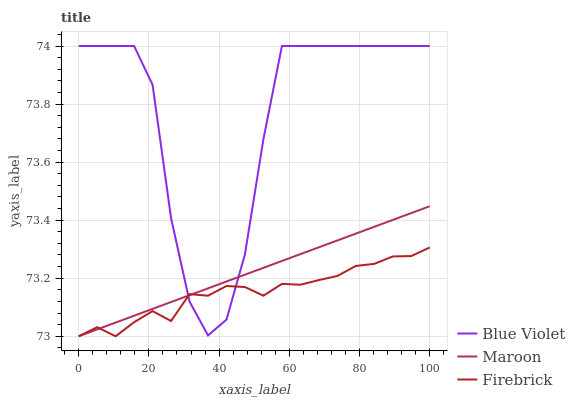Does Firebrick have the minimum area under the curve?
Answer yes or no. Yes. Does Blue Violet have the maximum area under the curve?
Answer yes or no. Yes. Does Maroon have the minimum area under the curve?
Answer yes or no. No. Does Maroon have the maximum area under the curve?
Answer yes or no. No. Is Maroon the smoothest?
Answer yes or no. Yes. Is Blue Violet the roughest?
Answer yes or no. Yes. Is Blue Violet the smoothest?
Answer yes or no. No. Is Maroon the roughest?
Answer yes or no. No. Does Firebrick have the lowest value?
Answer yes or no. Yes. Does Blue Violet have the lowest value?
Answer yes or no. No. Does Blue Violet have the highest value?
Answer yes or no. Yes. Does Maroon have the highest value?
Answer yes or no. No. Does Blue Violet intersect Maroon?
Answer yes or no. Yes. Is Blue Violet less than Maroon?
Answer yes or no. No. Is Blue Violet greater than Maroon?
Answer yes or no. No. 